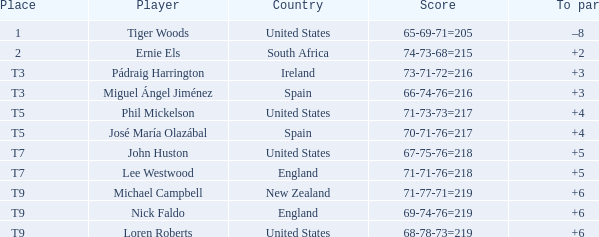What is Country, when Place is "T9", and when Player is "Michael Campbell"? New Zealand. 